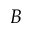Convert formula to latex. <formula><loc_0><loc_0><loc_500><loc_500>B</formula> 